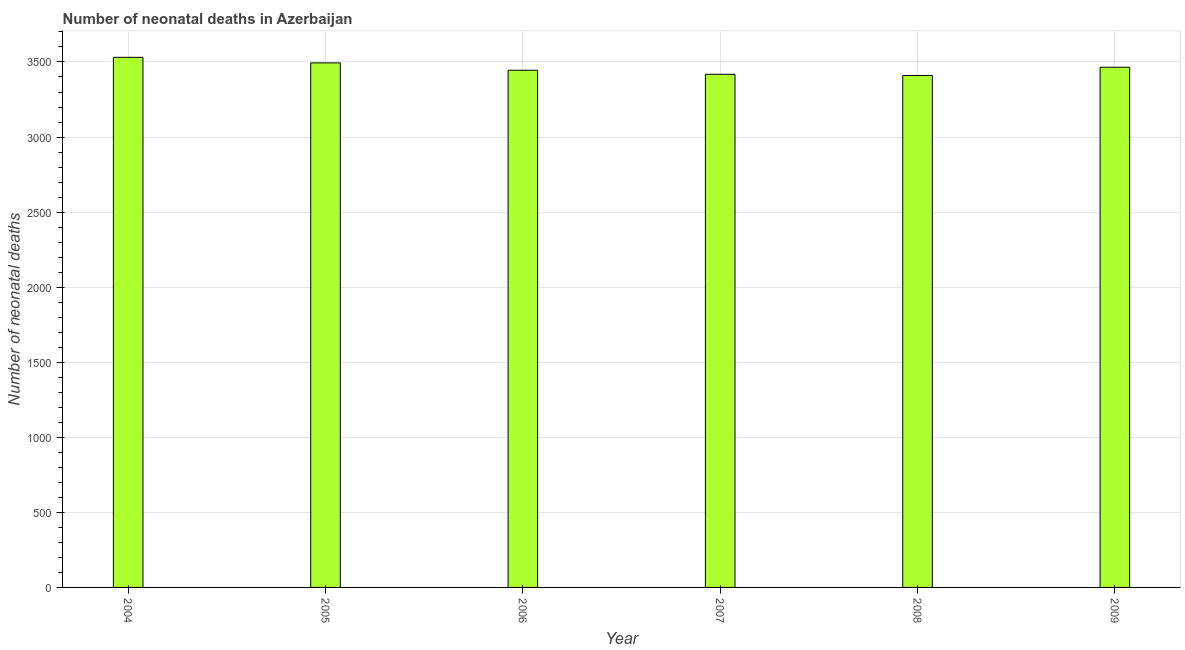Does the graph contain grids?
Give a very brief answer. Yes. What is the title of the graph?
Provide a succinct answer. Number of neonatal deaths in Azerbaijan. What is the label or title of the X-axis?
Make the answer very short. Year. What is the label or title of the Y-axis?
Your answer should be compact. Number of neonatal deaths. What is the number of neonatal deaths in 2007?
Make the answer very short. 3418. Across all years, what is the maximum number of neonatal deaths?
Your answer should be very brief. 3531. Across all years, what is the minimum number of neonatal deaths?
Your answer should be very brief. 3410. What is the sum of the number of neonatal deaths?
Offer a very short reply. 2.08e+04. What is the difference between the number of neonatal deaths in 2004 and 2008?
Give a very brief answer. 121. What is the average number of neonatal deaths per year?
Provide a short and direct response. 3460. What is the median number of neonatal deaths?
Make the answer very short. 3455. What is the ratio of the number of neonatal deaths in 2005 to that in 2007?
Provide a succinct answer. 1.02. Is the number of neonatal deaths in 2004 less than that in 2007?
Your answer should be very brief. No. Is the difference between the number of neonatal deaths in 2004 and 2008 greater than the difference between any two years?
Your response must be concise. Yes. What is the difference between the highest and the second highest number of neonatal deaths?
Make the answer very short. 37. Is the sum of the number of neonatal deaths in 2006 and 2007 greater than the maximum number of neonatal deaths across all years?
Ensure brevity in your answer.  Yes. What is the difference between the highest and the lowest number of neonatal deaths?
Your answer should be very brief. 121. In how many years, is the number of neonatal deaths greater than the average number of neonatal deaths taken over all years?
Provide a short and direct response. 3. How many bars are there?
Your response must be concise. 6. Are all the bars in the graph horizontal?
Give a very brief answer. No. How many years are there in the graph?
Make the answer very short. 6. What is the difference between two consecutive major ticks on the Y-axis?
Give a very brief answer. 500. What is the Number of neonatal deaths of 2004?
Your response must be concise. 3531. What is the Number of neonatal deaths of 2005?
Your answer should be very brief. 3494. What is the Number of neonatal deaths of 2006?
Provide a short and direct response. 3445. What is the Number of neonatal deaths of 2007?
Your response must be concise. 3418. What is the Number of neonatal deaths of 2008?
Offer a very short reply. 3410. What is the Number of neonatal deaths in 2009?
Your answer should be very brief. 3465. What is the difference between the Number of neonatal deaths in 2004 and 2007?
Provide a succinct answer. 113. What is the difference between the Number of neonatal deaths in 2004 and 2008?
Keep it short and to the point. 121. What is the difference between the Number of neonatal deaths in 2004 and 2009?
Make the answer very short. 66. What is the difference between the Number of neonatal deaths in 2006 and 2008?
Make the answer very short. 35. What is the difference between the Number of neonatal deaths in 2006 and 2009?
Your answer should be very brief. -20. What is the difference between the Number of neonatal deaths in 2007 and 2008?
Your answer should be very brief. 8. What is the difference between the Number of neonatal deaths in 2007 and 2009?
Give a very brief answer. -47. What is the difference between the Number of neonatal deaths in 2008 and 2009?
Provide a succinct answer. -55. What is the ratio of the Number of neonatal deaths in 2004 to that in 2005?
Your answer should be very brief. 1.01. What is the ratio of the Number of neonatal deaths in 2004 to that in 2006?
Make the answer very short. 1.02. What is the ratio of the Number of neonatal deaths in 2004 to that in 2007?
Provide a succinct answer. 1.03. What is the ratio of the Number of neonatal deaths in 2004 to that in 2008?
Your response must be concise. 1.03. What is the ratio of the Number of neonatal deaths in 2005 to that in 2006?
Keep it short and to the point. 1.01. What is the ratio of the Number of neonatal deaths in 2005 to that in 2007?
Make the answer very short. 1.02. What is the ratio of the Number of neonatal deaths in 2005 to that in 2008?
Give a very brief answer. 1.02. What is the ratio of the Number of neonatal deaths in 2006 to that in 2008?
Keep it short and to the point. 1.01. What is the ratio of the Number of neonatal deaths in 2006 to that in 2009?
Ensure brevity in your answer.  0.99. What is the ratio of the Number of neonatal deaths in 2007 to that in 2008?
Make the answer very short. 1. What is the ratio of the Number of neonatal deaths in 2007 to that in 2009?
Provide a short and direct response. 0.99. 